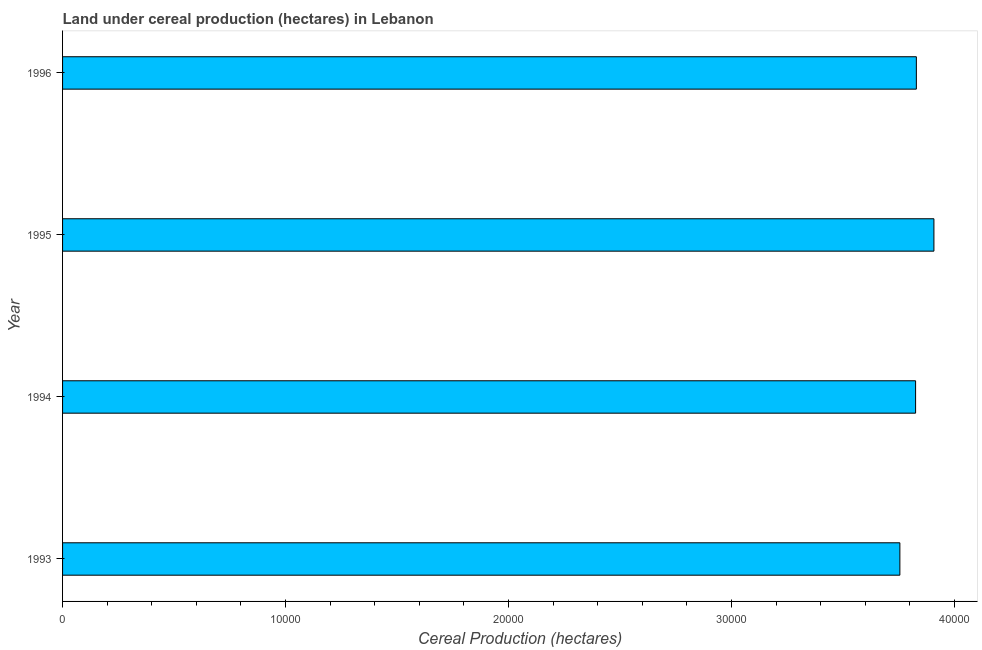Does the graph contain any zero values?
Provide a short and direct response. No. Does the graph contain grids?
Provide a succinct answer. No. What is the title of the graph?
Offer a very short reply. Land under cereal production (hectares) in Lebanon. What is the label or title of the X-axis?
Offer a terse response. Cereal Production (hectares). What is the land under cereal production in 1996?
Give a very brief answer. 3.83e+04. Across all years, what is the maximum land under cereal production?
Your answer should be very brief. 3.91e+04. Across all years, what is the minimum land under cereal production?
Your answer should be compact. 3.76e+04. What is the sum of the land under cereal production?
Offer a very short reply. 1.53e+05. What is the difference between the land under cereal production in 1994 and 1995?
Make the answer very short. -822. What is the average land under cereal production per year?
Offer a terse response. 3.83e+04. What is the median land under cereal production?
Ensure brevity in your answer.  3.83e+04. Do a majority of the years between 1993 and 1996 (inclusive) have land under cereal production greater than 12000 hectares?
Your answer should be compact. Yes. What is the ratio of the land under cereal production in 1994 to that in 1996?
Your answer should be compact. 1. What is the difference between the highest and the second highest land under cereal production?
Your answer should be compact. 788. What is the difference between the highest and the lowest land under cereal production?
Give a very brief answer. 1527. How many bars are there?
Keep it short and to the point. 4. Are all the bars in the graph horizontal?
Give a very brief answer. Yes. Are the values on the major ticks of X-axis written in scientific E-notation?
Provide a succinct answer. No. What is the Cereal Production (hectares) of 1993?
Offer a very short reply. 3.76e+04. What is the Cereal Production (hectares) of 1994?
Provide a short and direct response. 3.83e+04. What is the Cereal Production (hectares) of 1995?
Offer a very short reply. 3.91e+04. What is the Cereal Production (hectares) in 1996?
Make the answer very short. 3.83e+04. What is the difference between the Cereal Production (hectares) in 1993 and 1994?
Give a very brief answer. -705. What is the difference between the Cereal Production (hectares) in 1993 and 1995?
Make the answer very short. -1527. What is the difference between the Cereal Production (hectares) in 1993 and 1996?
Your response must be concise. -739. What is the difference between the Cereal Production (hectares) in 1994 and 1995?
Give a very brief answer. -822. What is the difference between the Cereal Production (hectares) in 1994 and 1996?
Provide a succinct answer. -34. What is the difference between the Cereal Production (hectares) in 1995 and 1996?
Give a very brief answer. 788. What is the ratio of the Cereal Production (hectares) in 1993 to that in 1994?
Ensure brevity in your answer.  0.98. What is the ratio of the Cereal Production (hectares) in 1993 to that in 1995?
Keep it short and to the point. 0.96. What is the ratio of the Cereal Production (hectares) in 1993 to that in 1996?
Provide a short and direct response. 0.98. What is the ratio of the Cereal Production (hectares) in 1994 to that in 1996?
Ensure brevity in your answer.  1. What is the ratio of the Cereal Production (hectares) in 1995 to that in 1996?
Your answer should be compact. 1.02. 